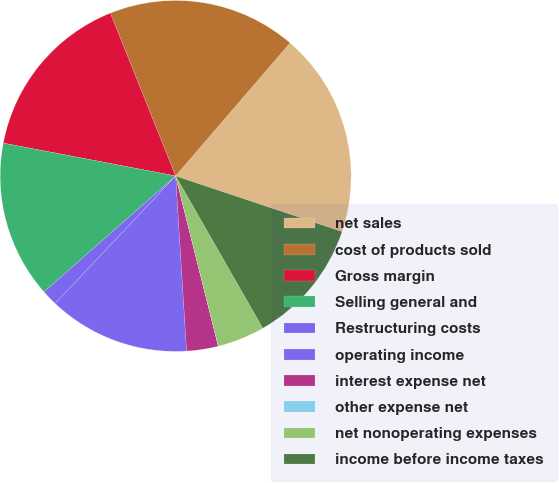Convert chart. <chart><loc_0><loc_0><loc_500><loc_500><pie_chart><fcel>net sales<fcel>cost of products sold<fcel>Gross margin<fcel>Selling general and<fcel>Restructuring costs<fcel>operating income<fcel>interest expense net<fcel>other expense net<fcel>net nonoperating expenses<fcel>income before income taxes<nl><fcel>18.83%<fcel>17.38%<fcel>15.93%<fcel>14.49%<fcel>1.46%<fcel>13.04%<fcel>2.91%<fcel>0.01%<fcel>4.36%<fcel>11.59%<nl></chart> 